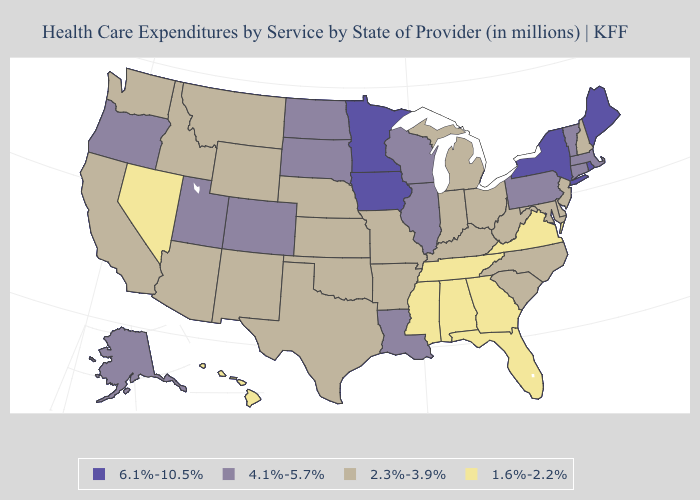Name the states that have a value in the range 2.3%-3.9%?
Short answer required. Arizona, Arkansas, California, Delaware, Idaho, Indiana, Kansas, Kentucky, Maryland, Michigan, Missouri, Montana, Nebraska, New Hampshire, New Jersey, New Mexico, North Carolina, Ohio, Oklahoma, South Carolina, Texas, Washington, West Virginia, Wyoming. Does Massachusetts have the highest value in the Northeast?
Give a very brief answer. No. Does Texas have a lower value than Minnesota?
Answer briefly. Yes. Name the states that have a value in the range 6.1%-10.5%?
Give a very brief answer. Iowa, Maine, Minnesota, New York, Rhode Island. What is the value of New Hampshire?
Answer briefly. 2.3%-3.9%. What is the lowest value in states that border North Carolina?
Give a very brief answer. 1.6%-2.2%. What is the value of Delaware?
Be succinct. 2.3%-3.9%. Does Oklahoma have the lowest value in the South?
Quick response, please. No. Does Georgia have the lowest value in the USA?
Concise answer only. Yes. Does Indiana have a lower value than New Jersey?
Give a very brief answer. No. Name the states that have a value in the range 2.3%-3.9%?
Be succinct. Arizona, Arkansas, California, Delaware, Idaho, Indiana, Kansas, Kentucky, Maryland, Michigan, Missouri, Montana, Nebraska, New Hampshire, New Jersey, New Mexico, North Carolina, Ohio, Oklahoma, South Carolina, Texas, Washington, West Virginia, Wyoming. Name the states that have a value in the range 2.3%-3.9%?
Be succinct. Arizona, Arkansas, California, Delaware, Idaho, Indiana, Kansas, Kentucky, Maryland, Michigan, Missouri, Montana, Nebraska, New Hampshire, New Jersey, New Mexico, North Carolina, Ohio, Oklahoma, South Carolina, Texas, Washington, West Virginia, Wyoming. Which states have the lowest value in the USA?
Concise answer only. Alabama, Florida, Georgia, Hawaii, Mississippi, Nevada, Tennessee, Virginia. Among the states that border Maine , which have the lowest value?
Write a very short answer. New Hampshire. Name the states that have a value in the range 2.3%-3.9%?
Keep it brief. Arizona, Arkansas, California, Delaware, Idaho, Indiana, Kansas, Kentucky, Maryland, Michigan, Missouri, Montana, Nebraska, New Hampshire, New Jersey, New Mexico, North Carolina, Ohio, Oklahoma, South Carolina, Texas, Washington, West Virginia, Wyoming. 